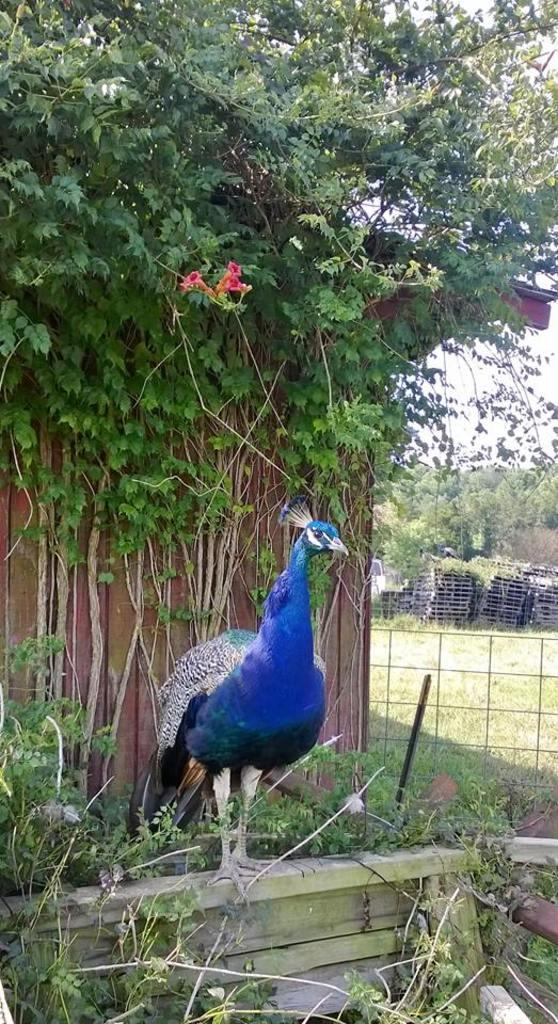What type of animal is in the picture? There is a peacock in the picture. What other living organisms can be seen in the picture? There are a few plants in the picture. What can be seen in the background of the picture? There are objects and trees visible in the background of the picture. What color is the paint used to decorate the peacock's feathers in the image? There is no paint visible on the peacock's feathers in the image, as the peacock's colors are natural. 